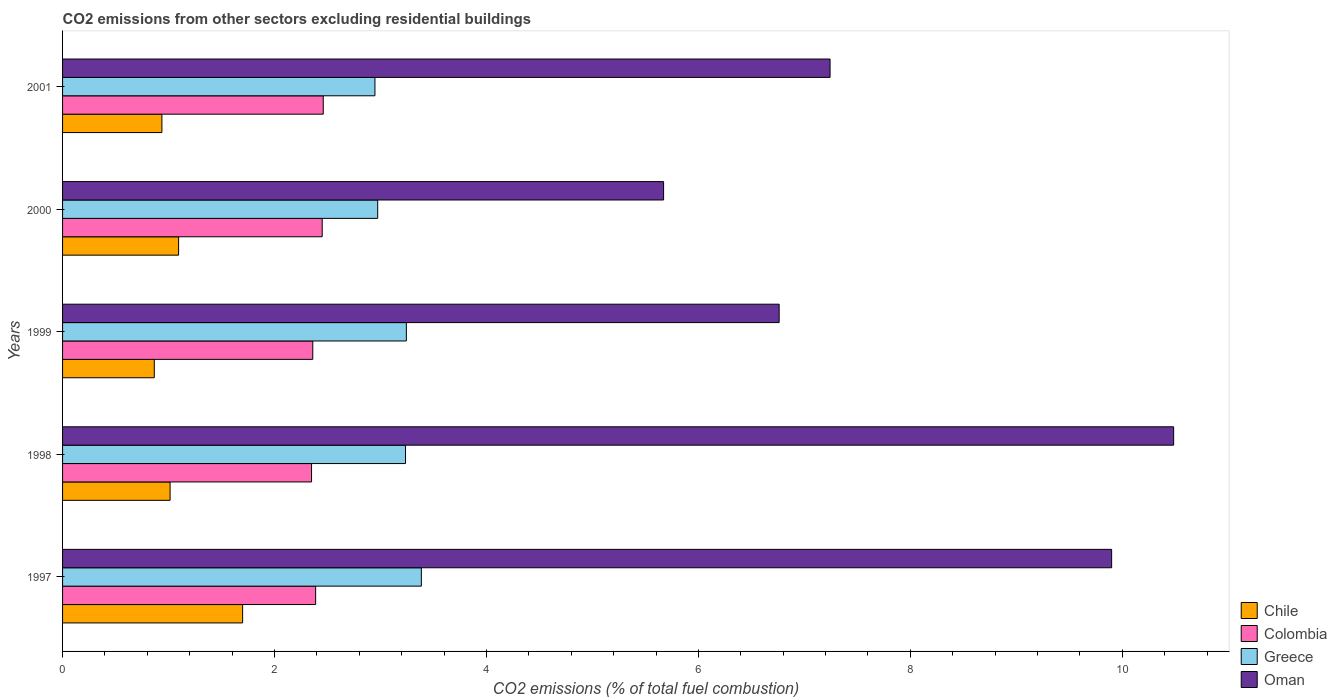How many different coloured bars are there?
Ensure brevity in your answer.  4. Are the number of bars per tick equal to the number of legend labels?
Give a very brief answer. Yes. How many bars are there on the 5th tick from the top?
Ensure brevity in your answer.  4. What is the label of the 2nd group of bars from the top?
Give a very brief answer. 2000. What is the total CO2 emitted in Colombia in 2001?
Keep it short and to the point. 2.46. Across all years, what is the maximum total CO2 emitted in Greece?
Your answer should be very brief. 3.39. Across all years, what is the minimum total CO2 emitted in Oman?
Ensure brevity in your answer.  5.67. What is the total total CO2 emitted in Colombia in the graph?
Offer a terse response. 12.01. What is the difference between the total CO2 emitted in Colombia in 1997 and that in 1998?
Your answer should be compact. 0.04. What is the difference between the total CO2 emitted in Greece in 2000 and the total CO2 emitted in Oman in 1998?
Your answer should be compact. -7.51. What is the average total CO2 emitted in Oman per year?
Give a very brief answer. 8.01. In the year 2000, what is the difference between the total CO2 emitted in Colombia and total CO2 emitted in Oman?
Keep it short and to the point. -3.22. In how many years, is the total CO2 emitted in Chile greater than 10 ?
Offer a terse response. 0. What is the ratio of the total CO2 emitted in Colombia in 2000 to that in 2001?
Provide a short and direct response. 1. Is the total CO2 emitted in Greece in 1997 less than that in 1999?
Your answer should be very brief. No. Is the difference between the total CO2 emitted in Colombia in 1999 and 2001 greater than the difference between the total CO2 emitted in Oman in 1999 and 2001?
Provide a short and direct response. Yes. What is the difference between the highest and the second highest total CO2 emitted in Greece?
Ensure brevity in your answer.  0.14. What is the difference between the highest and the lowest total CO2 emitted in Greece?
Offer a terse response. 0.44. Is the sum of the total CO2 emitted in Oman in 1999 and 2000 greater than the maximum total CO2 emitted in Chile across all years?
Offer a very short reply. Yes. Is it the case that in every year, the sum of the total CO2 emitted in Chile and total CO2 emitted in Greece is greater than the total CO2 emitted in Colombia?
Offer a terse response. Yes. How many bars are there?
Provide a succinct answer. 20. Are all the bars in the graph horizontal?
Provide a short and direct response. Yes. How many years are there in the graph?
Offer a very short reply. 5. What is the difference between two consecutive major ticks on the X-axis?
Provide a short and direct response. 2. Are the values on the major ticks of X-axis written in scientific E-notation?
Keep it short and to the point. No. Does the graph contain any zero values?
Ensure brevity in your answer.  No. Where does the legend appear in the graph?
Your answer should be very brief. Bottom right. How are the legend labels stacked?
Offer a very short reply. Vertical. What is the title of the graph?
Ensure brevity in your answer.  CO2 emissions from other sectors excluding residential buildings. Does "East Asia (developing only)" appear as one of the legend labels in the graph?
Give a very brief answer. No. What is the label or title of the X-axis?
Ensure brevity in your answer.  CO2 emissions (% of total fuel combustion). What is the CO2 emissions (% of total fuel combustion) of Chile in 1997?
Your answer should be very brief. 1.7. What is the CO2 emissions (% of total fuel combustion) in Colombia in 1997?
Keep it short and to the point. 2.39. What is the CO2 emissions (% of total fuel combustion) of Greece in 1997?
Ensure brevity in your answer.  3.39. What is the CO2 emissions (% of total fuel combustion) in Oman in 1997?
Your answer should be very brief. 9.9. What is the CO2 emissions (% of total fuel combustion) of Chile in 1998?
Provide a succinct answer. 1.01. What is the CO2 emissions (% of total fuel combustion) of Colombia in 1998?
Offer a terse response. 2.35. What is the CO2 emissions (% of total fuel combustion) in Greece in 1998?
Give a very brief answer. 3.24. What is the CO2 emissions (% of total fuel combustion) in Oman in 1998?
Provide a short and direct response. 10.48. What is the CO2 emissions (% of total fuel combustion) of Chile in 1999?
Your answer should be compact. 0.87. What is the CO2 emissions (% of total fuel combustion) in Colombia in 1999?
Provide a succinct answer. 2.36. What is the CO2 emissions (% of total fuel combustion) of Greece in 1999?
Your answer should be very brief. 3.24. What is the CO2 emissions (% of total fuel combustion) of Oman in 1999?
Keep it short and to the point. 6.76. What is the CO2 emissions (% of total fuel combustion) in Chile in 2000?
Your answer should be compact. 1.09. What is the CO2 emissions (% of total fuel combustion) of Colombia in 2000?
Offer a very short reply. 2.45. What is the CO2 emissions (% of total fuel combustion) in Greece in 2000?
Provide a short and direct response. 2.97. What is the CO2 emissions (% of total fuel combustion) in Oman in 2000?
Your response must be concise. 5.67. What is the CO2 emissions (% of total fuel combustion) in Chile in 2001?
Keep it short and to the point. 0.94. What is the CO2 emissions (% of total fuel combustion) of Colombia in 2001?
Your response must be concise. 2.46. What is the CO2 emissions (% of total fuel combustion) in Greece in 2001?
Offer a very short reply. 2.95. What is the CO2 emissions (% of total fuel combustion) of Oman in 2001?
Keep it short and to the point. 7.24. Across all years, what is the maximum CO2 emissions (% of total fuel combustion) in Chile?
Offer a very short reply. 1.7. Across all years, what is the maximum CO2 emissions (% of total fuel combustion) of Colombia?
Give a very brief answer. 2.46. Across all years, what is the maximum CO2 emissions (% of total fuel combustion) of Greece?
Make the answer very short. 3.39. Across all years, what is the maximum CO2 emissions (% of total fuel combustion) in Oman?
Your response must be concise. 10.48. Across all years, what is the minimum CO2 emissions (% of total fuel combustion) in Chile?
Keep it short and to the point. 0.87. Across all years, what is the minimum CO2 emissions (% of total fuel combustion) of Colombia?
Ensure brevity in your answer.  2.35. Across all years, what is the minimum CO2 emissions (% of total fuel combustion) of Greece?
Your answer should be very brief. 2.95. Across all years, what is the minimum CO2 emissions (% of total fuel combustion) of Oman?
Your response must be concise. 5.67. What is the total CO2 emissions (% of total fuel combustion) of Chile in the graph?
Ensure brevity in your answer.  5.61. What is the total CO2 emissions (% of total fuel combustion) of Colombia in the graph?
Provide a short and direct response. 12.01. What is the total CO2 emissions (% of total fuel combustion) of Greece in the graph?
Your answer should be compact. 15.79. What is the total CO2 emissions (% of total fuel combustion) of Oman in the graph?
Give a very brief answer. 40.06. What is the difference between the CO2 emissions (% of total fuel combustion) in Chile in 1997 and that in 1998?
Make the answer very short. 0.68. What is the difference between the CO2 emissions (% of total fuel combustion) in Colombia in 1997 and that in 1998?
Offer a terse response. 0.04. What is the difference between the CO2 emissions (% of total fuel combustion) in Greece in 1997 and that in 1998?
Give a very brief answer. 0.15. What is the difference between the CO2 emissions (% of total fuel combustion) of Oman in 1997 and that in 1998?
Your answer should be very brief. -0.59. What is the difference between the CO2 emissions (% of total fuel combustion) of Chile in 1997 and that in 1999?
Ensure brevity in your answer.  0.83. What is the difference between the CO2 emissions (% of total fuel combustion) of Colombia in 1997 and that in 1999?
Your response must be concise. 0.03. What is the difference between the CO2 emissions (% of total fuel combustion) in Greece in 1997 and that in 1999?
Make the answer very short. 0.14. What is the difference between the CO2 emissions (% of total fuel combustion) of Oman in 1997 and that in 1999?
Ensure brevity in your answer.  3.14. What is the difference between the CO2 emissions (% of total fuel combustion) in Chile in 1997 and that in 2000?
Make the answer very short. 0.6. What is the difference between the CO2 emissions (% of total fuel combustion) of Colombia in 1997 and that in 2000?
Provide a succinct answer. -0.06. What is the difference between the CO2 emissions (% of total fuel combustion) in Greece in 1997 and that in 2000?
Provide a succinct answer. 0.41. What is the difference between the CO2 emissions (% of total fuel combustion) of Oman in 1997 and that in 2000?
Your answer should be compact. 4.23. What is the difference between the CO2 emissions (% of total fuel combustion) in Chile in 1997 and that in 2001?
Provide a short and direct response. 0.76. What is the difference between the CO2 emissions (% of total fuel combustion) in Colombia in 1997 and that in 2001?
Give a very brief answer. -0.07. What is the difference between the CO2 emissions (% of total fuel combustion) in Greece in 1997 and that in 2001?
Provide a succinct answer. 0.44. What is the difference between the CO2 emissions (% of total fuel combustion) of Oman in 1997 and that in 2001?
Offer a terse response. 2.66. What is the difference between the CO2 emissions (% of total fuel combustion) of Chile in 1998 and that in 1999?
Give a very brief answer. 0.15. What is the difference between the CO2 emissions (% of total fuel combustion) of Colombia in 1998 and that in 1999?
Make the answer very short. -0.01. What is the difference between the CO2 emissions (% of total fuel combustion) of Greece in 1998 and that in 1999?
Ensure brevity in your answer.  -0.01. What is the difference between the CO2 emissions (% of total fuel combustion) in Oman in 1998 and that in 1999?
Keep it short and to the point. 3.72. What is the difference between the CO2 emissions (% of total fuel combustion) in Chile in 1998 and that in 2000?
Make the answer very short. -0.08. What is the difference between the CO2 emissions (% of total fuel combustion) in Colombia in 1998 and that in 2000?
Keep it short and to the point. -0.1. What is the difference between the CO2 emissions (% of total fuel combustion) in Greece in 1998 and that in 2000?
Provide a short and direct response. 0.26. What is the difference between the CO2 emissions (% of total fuel combustion) in Oman in 1998 and that in 2000?
Make the answer very short. 4.81. What is the difference between the CO2 emissions (% of total fuel combustion) of Chile in 1998 and that in 2001?
Make the answer very short. 0.08. What is the difference between the CO2 emissions (% of total fuel combustion) of Colombia in 1998 and that in 2001?
Your answer should be very brief. -0.11. What is the difference between the CO2 emissions (% of total fuel combustion) in Greece in 1998 and that in 2001?
Ensure brevity in your answer.  0.29. What is the difference between the CO2 emissions (% of total fuel combustion) in Oman in 1998 and that in 2001?
Ensure brevity in your answer.  3.24. What is the difference between the CO2 emissions (% of total fuel combustion) in Chile in 1999 and that in 2000?
Give a very brief answer. -0.23. What is the difference between the CO2 emissions (% of total fuel combustion) in Colombia in 1999 and that in 2000?
Give a very brief answer. -0.09. What is the difference between the CO2 emissions (% of total fuel combustion) of Greece in 1999 and that in 2000?
Give a very brief answer. 0.27. What is the difference between the CO2 emissions (% of total fuel combustion) in Oman in 1999 and that in 2000?
Keep it short and to the point. 1.09. What is the difference between the CO2 emissions (% of total fuel combustion) in Chile in 1999 and that in 2001?
Provide a short and direct response. -0.07. What is the difference between the CO2 emissions (% of total fuel combustion) in Colombia in 1999 and that in 2001?
Keep it short and to the point. -0.1. What is the difference between the CO2 emissions (% of total fuel combustion) in Greece in 1999 and that in 2001?
Ensure brevity in your answer.  0.3. What is the difference between the CO2 emissions (% of total fuel combustion) in Oman in 1999 and that in 2001?
Provide a short and direct response. -0.48. What is the difference between the CO2 emissions (% of total fuel combustion) in Chile in 2000 and that in 2001?
Give a very brief answer. 0.16. What is the difference between the CO2 emissions (% of total fuel combustion) of Colombia in 2000 and that in 2001?
Your answer should be very brief. -0.01. What is the difference between the CO2 emissions (% of total fuel combustion) of Greece in 2000 and that in 2001?
Your answer should be very brief. 0.03. What is the difference between the CO2 emissions (% of total fuel combustion) in Oman in 2000 and that in 2001?
Offer a very short reply. -1.57. What is the difference between the CO2 emissions (% of total fuel combustion) of Chile in 1997 and the CO2 emissions (% of total fuel combustion) of Colombia in 1998?
Offer a terse response. -0.65. What is the difference between the CO2 emissions (% of total fuel combustion) of Chile in 1997 and the CO2 emissions (% of total fuel combustion) of Greece in 1998?
Your response must be concise. -1.54. What is the difference between the CO2 emissions (% of total fuel combustion) in Chile in 1997 and the CO2 emissions (% of total fuel combustion) in Oman in 1998?
Keep it short and to the point. -8.79. What is the difference between the CO2 emissions (% of total fuel combustion) of Colombia in 1997 and the CO2 emissions (% of total fuel combustion) of Greece in 1998?
Your answer should be compact. -0.85. What is the difference between the CO2 emissions (% of total fuel combustion) in Colombia in 1997 and the CO2 emissions (% of total fuel combustion) in Oman in 1998?
Ensure brevity in your answer.  -8.1. What is the difference between the CO2 emissions (% of total fuel combustion) of Greece in 1997 and the CO2 emissions (% of total fuel combustion) of Oman in 1998?
Provide a succinct answer. -7.1. What is the difference between the CO2 emissions (% of total fuel combustion) of Chile in 1997 and the CO2 emissions (% of total fuel combustion) of Colombia in 1999?
Provide a short and direct response. -0.66. What is the difference between the CO2 emissions (% of total fuel combustion) in Chile in 1997 and the CO2 emissions (% of total fuel combustion) in Greece in 1999?
Offer a terse response. -1.55. What is the difference between the CO2 emissions (% of total fuel combustion) in Chile in 1997 and the CO2 emissions (% of total fuel combustion) in Oman in 1999?
Make the answer very short. -5.06. What is the difference between the CO2 emissions (% of total fuel combustion) in Colombia in 1997 and the CO2 emissions (% of total fuel combustion) in Greece in 1999?
Your answer should be very brief. -0.86. What is the difference between the CO2 emissions (% of total fuel combustion) of Colombia in 1997 and the CO2 emissions (% of total fuel combustion) of Oman in 1999?
Provide a short and direct response. -4.37. What is the difference between the CO2 emissions (% of total fuel combustion) in Greece in 1997 and the CO2 emissions (% of total fuel combustion) in Oman in 1999?
Provide a short and direct response. -3.38. What is the difference between the CO2 emissions (% of total fuel combustion) in Chile in 1997 and the CO2 emissions (% of total fuel combustion) in Colombia in 2000?
Give a very brief answer. -0.75. What is the difference between the CO2 emissions (% of total fuel combustion) of Chile in 1997 and the CO2 emissions (% of total fuel combustion) of Greece in 2000?
Ensure brevity in your answer.  -1.27. What is the difference between the CO2 emissions (% of total fuel combustion) in Chile in 1997 and the CO2 emissions (% of total fuel combustion) in Oman in 2000?
Offer a terse response. -3.97. What is the difference between the CO2 emissions (% of total fuel combustion) of Colombia in 1997 and the CO2 emissions (% of total fuel combustion) of Greece in 2000?
Keep it short and to the point. -0.59. What is the difference between the CO2 emissions (% of total fuel combustion) of Colombia in 1997 and the CO2 emissions (% of total fuel combustion) of Oman in 2000?
Offer a terse response. -3.28. What is the difference between the CO2 emissions (% of total fuel combustion) of Greece in 1997 and the CO2 emissions (% of total fuel combustion) of Oman in 2000?
Your answer should be very brief. -2.29. What is the difference between the CO2 emissions (% of total fuel combustion) of Chile in 1997 and the CO2 emissions (% of total fuel combustion) of Colombia in 2001?
Keep it short and to the point. -0.76. What is the difference between the CO2 emissions (% of total fuel combustion) of Chile in 1997 and the CO2 emissions (% of total fuel combustion) of Greece in 2001?
Offer a very short reply. -1.25. What is the difference between the CO2 emissions (% of total fuel combustion) of Chile in 1997 and the CO2 emissions (% of total fuel combustion) of Oman in 2001?
Make the answer very short. -5.54. What is the difference between the CO2 emissions (% of total fuel combustion) of Colombia in 1997 and the CO2 emissions (% of total fuel combustion) of Greece in 2001?
Provide a short and direct response. -0.56. What is the difference between the CO2 emissions (% of total fuel combustion) in Colombia in 1997 and the CO2 emissions (% of total fuel combustion) in Oman in 2001?
Provide a short and direct response. -4.85. What is the difference between the CO2 emissions (% of total fuel combustion) in Greece in 1997 and the CO2 emissions (% of total fuel combustion) in Oman in 2001?
Give a very brief answer. -3.86. What is the difference between the CO2 emissions (% of total fuel combustion) in Chile in 1998 and the CO2 emissions (% of total fuel combustion) in Colombia in 1999?
Offer a very short reply. -1.35. What is the difference between the CO2 emissions (% of total fuel combustion) in Chile in 1998 and the CO2 emissions (% of total fuel combustion) in Greece in 1999?
Keep it short and to the point. -2.23. What is the difference between the CO2 emissions (% of total fuel combustion) in Chile in 1998 and the CO2 emissions (% of total fuel combustion) in Oman in 1999?
Offer a terse response. -5.75. What is the difference between the CO2 emissions (% of total fuel combustion) of Colombia in 1998 and the CO2 emissions (% of total fuel combustion) of Greece in 1999?
Your answer should be very brief. -0.89. What is the difference between the CO2 emissions (% of total fuel combustion) in Colombia in 1998 and the CO2 emissions (% of total fuel combustion) in Oman in 1999?
Your response must be concise. -4.41. What is the difference between the CO2 emissions (% of total fuel combustion) of Greece in 1998 and the CO2 emissions (% of total fuel combustion) of Oman in 1999?
Ensure brevity in your answer.  -3.53. What is the difference between the CO2 emissions (% of total fuel combustion) in Chile in 1998 and the CO2 emissions (% of total fuel combustion) in Colombia in 2000?
Give a very brief answer. -1.44. What is the difference between the CO2 emissions (% of total fuel combustion) of Chile in 1998 and the CO2 emissions (% of total fuel combustion) of Greece in 2000?
Make the answer very short. -1.96. What is the difference between the CO2 emissions (% of total fuel combustion) in Chile in 1998 and the CO2 emissions (% of total fuel combustion) in Oman in 2000?
Make the answer very short. -4.66. What is the difference between the CO2 emissions (% of total fuel combustion) of Colombia in 1998 and the CO2 emissions (% of total fuel combustion) of Greece in 2000?
Your answer should be compact. -0.62. What is the difference between the CO2 emissions (% of total fuel combustion) in Colombia in 1998 and the CO2 emissions (% of total fuel combustion) in Oman in 2000?
Provide a succinct answer. -3.32. What is the difference between the CO2 emissions (% of total fuel combustion) in Greece in 1998 and the CO2 emissions (% of total fuel combustion) in Oman in 2000?
Your response must be concise. -2.44. What is the difference between the CO2 emissions (% of total fuel combustion) of Chile in 1998 and the CO2 emissions (% of total fuel combustion) of Colombia in 2001?
Offer a very short reply. -1.45. What is the difference between the CO2 emissions (% of total fuel combustion) in Chile in 1998 and the CO2 emissions (% of total fuel combustion) in Greece in 2001?
Provide a short and direct response. -1.93. What is the difference between the CO2 emissions (% of total fuel combustion) of Chile in 1998 and the CO2 emissions (% of total fuel combustion) of Oman in 2001?
Make the answer very short. -6.23. What is the difference between the CO2 emissions (% of total fuel combustion) of Colombia in 1998 and the CO2 emissions (% of total fuel combustion) of Greece in 2001?
Make the answer very short. -0.6. What is the difference between the CO2 emissions (% of total fuel combustion) in Colombia in 1998 and the CO2 emissions (% of total fuel combustion) in Oman in 2001?
Your response must be concise. -4.89. What is the difference between the CO2 emissions (% of total fuel combustion) of Greece in 1998 and the CO2 emissions (% of total fuel combustion) of Oman in 2001?
Ensure brevity in your answer.  -4.01. What is the difference between the CO2 emissions (% of total fuel combustion) of Chile in 1999 and the CO2 emissions (% of total fuel combustion) of Colombia in 2000?
Ensure brevity in your answer.  -1.58. What is the difference between the CO2 emissions (% of total fuel combustion) of Chile in 1999 and the CO2 emissions (% of total fuel combustion) of Greece in 2000?
Keep it short and to the point. -2.11. What is the difference between the CO2 emissions (% of total fuel combustion) in Chile in 1999 and the CO2 emissions (% of total fuel combustion) in Oman in 2000?
Give a very brief answer. -4.81. What is the difference between the CO2 emissions (% of total fuel combustion) in Colombia in 1999 and the CO2 emissions (% of total fuel combustion) in Greece in 2000?
Offer a terse response. -0.61. What is the difference between the CO2 emissions (% of total fuel combustion) in Colombia in 1999 and the CO2 emissions (% of total fuel combustion) in Oman in 2000?
Make the answer very short. -3.31. What is the difference between the CO2 emissions (% of total fuel combustion) of Greece in 1999 and the CO2 emissions (% of total fuel combustion) of Oman in 2000?
Offer a very short reply. -2.43. What is the difference between the CO2 emissions (% of total fuel combustion) in Chile in 1999 and the CO2 emissions (% of total fuel combustion) in Colombia in 2001?
Make the answer very short. -1.59. What is the difference between the CO2 emissions (% of total fuel combustion) in Chile in 1999 and the CO2 emissions (% of total fuel combustion) in Greece in 2001?
Your response must be concise. -2.08. What is the difference between the CO2 emissions (% of total fuel combustion) of Chile in 1999 and the CO2 emissions (% of total fuel combustion) of Oman in 2001?
Give a very brief answer. -6.38. What is the difference between the CO2 emissions (% of total fuel combustion) in Colombia in 1999 and the CO2 emissions (% of total fuel combustion) in Greece in 2001?
Offer a very short reply. -0.59. What is the difference between the CO2 emissions (% of total fuel combustion) in Colombia in 1999 and the CO2 emissions (% of total fuel combustion) in Oman in 2001?
Ensure brevity in your answer.  -4.88. What is the difference between the CO2 emissions (% of total fuel combustion) in Greece in 1999 and the CO2 emissions (% of total fuel combustion) in Oman in 2001?
Provide a short and direct response. -4. What is the difference between the CO2 emissions (% of total fuel combustion) in Chile in 2000 and the CO2 emissions (% of total fuel combustion) in Colombia in 2001?
Give a very brief answer. -1.37. What is the difference between the CO2 emissions (% of total fuel combustion) of Chile in 2000 and the CO2 emissions (% of total fuel combustion) of Greece in 2001?
Provide a short and direct response. -1.85. What is the difference between the CO2 emissions (% of total fuel combustion) of Chile in 2000 and the CO2 emissions (% of total fuel combustion) of Oman in 2001?
Offer a very short reply. -6.15. What is the difference between the CO2 emissions (% of total fuel combustion) of Colombia in 2000 and the CO2 emissions (% of total fuel combustion) of Greece in 2001?
Provide a succinct answer. -0.5. What is the difference between the CO2 emissions (% of total fuel combustion) of Colombia in 2000 and the CO2 emissions (% of total fuel combustion) of Oman in 2001?
Give a very brief answer. -4.79. What is the difference between the CO2 emissions (% of total fuel combustion) in Greece in 2000 and the CO2 emissions (% of total fuel combustion) in Oman in 2001?
Keep it short and to the point. -4.27. What is the average CO2 emissions (% of total fuel combustion) of Chile per year?
Offer a terse response. 1.12. What is the average CO2 emissions (% of total fuel combustion) of Colombia per year?
Make the answer very short. 2.4. What is the average CO2 emissions (% of total fuel combustion) of Greece per year?
Offer a terse response. 3.16. What is the average CO2 emissions (% of total fuel combustion) of Oman per year?
Offer a terse response. 8.01. In the year 1997, what is the difference between the CO2 emissions (% of total fuel combustion) of Chile and CO2 emissions (% of total fuel combustion) of Colombia?
Provide a succinct answer. -0.69. In the year 1997, what is the difference between the CO2 emissions (% of total fuel combustion) of Chile and CO2 emissions (% of total fuel combustion) of Greece?
Your response must be concise. -1.69. In the year 1997, what is the difference between the CO2 emissions (% of total fuel combustion) in Chile and CO2 emissions (% of total fuel combustion) in Oman?
Keep it short and to the point. -8.2. In the year 1997, what is the difference between the CO2 emissions (% of total fuel combustion) of Colombia and CO2 emissions (% of total fuel combustion) of Greece?
Your answer should be very brief. -1. In the year 1997, what is the difference between the CO2 emissions (% of total fuel combustion) in Colombia and CO2 emissions (% of total fuel combustion) in Oman?
Keep it short and to the point. -7.51. In the year 1997, what is the difference between the CO2 emissions (% of total fuel combustion) in Greece and CO2 emissions (% of total fuel combustion) in Oman?
Keep it short and to the point. -6.51. In the year 1998, what is the difference between the CO2 emissions (% of total fuel combustion) of Chile and CO2 emissions (% of total fuel combustion) of Colombia?
Offer a terse response. -1.33. In the year 1998, what is the difference between the CO2 emissions (% of total fuel combustion) of Chile and CO2 emissions (% of total fuel combustion) of Greece?
Provide a short and direct response. -2.22. In the year 1998, what is the difference between the CO2 emissions (% of total fuel combustion) in Chile and CO2 emissions (% of total fuel combustion) in Oman?
Provide a short and direct response. -9.47. In the year 1998, what is the difference between the CO2 emissions (% of total fuel combustion) of Colombia and CO2 emissions (% of total fuel combustion) of Greece?
Offer a terse response. -0.89. In the year 1998, what is the difference between the CO2 emissions (% of total fuel combustion) of Colombia and CO2 emissions (% of total fuel combustion) of Oman?
Your answer should be compact. -8.14. In the year 1998, what is the difference between the CO2 emissions (% of total fuel combustion) in Greece and CO2 emissions (% of total fuel combustion) in Oman?
Provide a succinct answer. -7.25. In the year 1999, what is the difference between the CO2 emissions (% of total fuel combustion) of Chile and CO2 emissions (% of total fuel combustion) of Colombia?
Your response must be concise. -1.5. In the year 1999, what is the difference between the CO2 emissions (% of total fuel combustion) in Chile and CO2 emissions (% of total fuel combustion) in Greece?
Your answer should be compact. -2.38. In the year 1999, what is the difference between the CO2 emissions (% of total fuel combustion) of Chile and CO2 emissions (% of total fuel combustion) of Oman?
Your answer should be very brief. -5.9. In the year 1999, what is the difference between the CO2 emissions (% of total fuel combustion) in Colombia and CO2 emissions (% of total fuel combustion) in Greece?
Provide a short and direct response. -0.88. In the year 1999, what is the difference between the CO2 emissions (% of total fuel combustion) in Colombia and CO2 emissions (% of total fuel combustion) in Oman?
Ensure brevity in your answer.  -4.4. In the year 1999, what is the difference between the CO2 emissions (% of total fuel combustion) of Greece and CO2 emissions (% of total fuel combustion) of Oman?
Make the answer very short. -3.52. In the year 2000, what is the difference between the CO2 emissions (% of total fuel combustion) of Chile and CO2 emissions (% of total fuel combustion) of Colombia?
Give a very brief answer. -1.36. In the year 2000, what is the difference between the CO2 emissions (% of total fuel combustion) of Chile and CO2 emissions (% of total fuel combustion) of Greece?
Give a very brief answer. -1.88. In the year 2000, what is the difference between the CO2 emissions (% of total fuel combustion) in Chile and CO2 emissions (% of total fuel combustion) in Oman?
Offer a terse response. -4.58. In the year 2000, what is the difference between the CO2 emissions (% of total fuel combustion) in Colombia and CO2 emissions (% of total fuel combustion) in Greece?
Give a very brief answer. -0.52. In the year 2000, what is the difference between the CO2 emissions (% of total fuel combustion) in Colombia and CO2 emissions (% of total fuel combustion) in Oman?
Offer a very short reply. -3.22. In the year 2000, what is the difference between the CO2 emissions (% of total fuel combustion) of Greece and CO2 emissions (% of total fuel combustion) of Oman?
Give a very brief answer. -2.7. In the year 2001, what is the difference between the CO2 emissions (% of total fuel combustion) of Chile and CO2 emissions (% of total fuel combustion) of Colombia?
Offer a very short reply. -1.52. In the year 2001, what is the difference between the CO2 emissions (% of total fuel combustion) in Chile and CO2 emissions (% of total fuel combustion) in Greece?
Provide a short and direct response. -2.01. In the year 2001, what is the difference between the CO2 emissions (% of total fuel combustion) of Chile and CO2 emissions (% of total fuel combustion) of Oman?
Ensure brevity in your answer.  -6.31. In the year 2001, what is the difference between the CO2 emissions (% of total fuel combustion) of Colombia and CO2 emissions (% of total fuel combustion) of Greece?
Make the answer very short. -0.49. In the year 2001, what is the difference between the CO2 emissions (% of total fuel combustion) in Colombia and CO2 emissions (% of total fuel combustion) in Oman?
Offer a terse response. -4.78. In the year 2001, what is the difference between the CO2 emissions (% of total fuel combustion) in Greece and CO2 emissions (% of total fuel combustion) in Oman?
Provide a short and direct response. -4.29. What is the ratio of the CO2 emissions (% of total fuel combustion) in Chile in 1997 to that in 1998?
Your response must be concise. 1.67. What is the ratio of the CO2 emissions (% of total fuel combustion) of Colombia in 1997 to that in 1998?
Give a very brief answer. 1.02. What is the ratio of the CO2 emissions (% of total fuel combustion) of Greece in 1997 to that in 1998?
Ensure brevity in your answer.  1.05. What is the ratio of the CO2 emissions (% of total fuel combustion) in Oman in 1997 to that in 1998?
Ensure brevity in your answer.  0.94. What is the ratio of the CO2 emissions (% of total fuel combustion) of Chile in 1997 to that in 1999?
Provide a succinct answer. 1.96. What is the ratio of the CO2 emissions (% of total fuel combustion) of Colombia in 1997 to that in 1999?
Your response must be concise. 1.01. What is the ratio of the CO2 emissions (% of total fuel combustion) of Greece in 1997 to that in 1999?
Provide a succinct answer. 1.04. What is the ratio of the CO2 emissions (% of total fuel combustion) of Oman in 1997 to that in 1999?
Make the answer very short. 1.46. What is the ratio of the CO2 emissions (% of total fuel combustion) in Chile in 1997 to that in 2000?
Give a very brief answer. 1.55. What is the ratio of the CO2 emissions (% of total fuel combustion) of Colombia in 1997 to that in 2000?
Offer a terse response. 0.97. What is the ratio of the CO2 emissions (% of total fuel combustion) of Greece in 1997 to that in 2000?
Provide a succinct answer. 1.14. What is the ratio of the CO2 emissions (% of total fuel combustion) in Oman in 1997 to that in 2000?
Provide a short and direct response. 1.75. What is the ratio of the CO2 emissions (% of total fuel combustion) of Chile in 1997 to that in 2001?
Offer a very short reply. 1.81. What is the ratio of the CO2 emissions (% of total fuel combustion) in Colombia in 1997 to that in 2001?
Provide a short and direct response. 0.97. What is the ratio of the CO2 emissions (% of total fuel combustion) of Greece in 1997 to that in 2001?
Your answer should be compact. 1.15. What is the ratio of the CO2 emissions (% of total fuel combustion) of Oman in 1997 to that in 2001?
Your response must be concise. 1.37. What is the ratio of the CO2 emissions (% of total fuel combustion) of Chile in 1998 to that in 1999?
Your response must be concise. 1.17. What is the ratio of the CO2 emissions (% of total fuel combustion) of Colombia in 1998 to that in 1999?
Give a very brief answer. 0.99. What is the ratio of the CO2 emissions (% of total fuel combustion) of Greece in 1998 to that in 1999?
Your answer should be very brief. 1. What is the ratio of the CO2 emissions (% of total fuel combustion) in Oman in 1998 to that in 1999?
Your response must be concise. 1.55. What is the ratio of the CO2 emissions (% of total fuel combustion) of Chile in 1998 to that in 2000?
Offer a very short reply. 0.93. What is the ratio of the CO2 emissions (% of total fuel combustion) of Colombia in 1998 to that in 2000?
Give a very brief answer. 0.96. What is the ratio of the CO2 emissions (% of total fuel combustion) of Greece in 1998 to that in 2000?
Make the answer very short. 1.09. What is the ratio of the CO2 emissions (% of total fuel combustion) of Oman in 1998 to that in 2000?
Offer a terse response. 1.85. What is the ratio of the CO2 emissions (% of total fuel combustion) in Chile in 1998 to that in 2001?
Your answer should be very brief. 1.08. What is the ratio of the CO2 emissions (% of total fuel combustion) in Colombia in 1998 to that in 2001?
Keep it short and to the point. 0.96. What is the ratio of the CO2 emissions (% of total fuel combustion) of Greece in 1998 to that in 2001?
Your response must be concise. 1.1. What is the ratio of the CO2 emissions (% of total fuel combustion) in Oman in 1998 to that in 2001?
Keep it short and to the point. 1.45. What is the ratio of the CO2 emissions (% of total fuel combustion) of Chile in 1999 to that in 2000?
Ensure brevity in your answer.  0.79. What is the ratio of the CO2 emissions (% of total fuel combustion) of Colombia in 1999 to that in 2000?
Keep it short and to the point. 0.96. What is the ratio of the CO2 emissions (% of total fuel combustion) in Oman in 1999 to that in 2000?
Keep it short and to the point. 1.19. What is the ratio of the CO2 emissions (% of total fuel combustion) of Chile in 1999 to that in 2001?
Your response must be concise. 0.92. What is the ratio of the CO2 emissions (% of total fuel combustion) in Colombia in 1999 to that in 2001?
Your response must be concise. 0.96. What is the ratio of the CO2 emissions (% of total fuel combustion) of Greece in 1999 to that in 2001?
Provide a short and direct response. 1.1. What is the ratio of the CO2 emissions (% of total fuel combustion) in Oman in 1999 to that in 2001?
Your answer should be very brief. 0.93. What is the ratio of the CO2 emissions (% of total fuel combustion) of Chile in 2000 to that in 2001?
Your response must be concise. 1.17. What is the ratio of the CO2 emissions (% of total fuel combustion) in Greece in 2000 to that in 2001?
Your answer should be very brief. 1.01. What is the ratio of the CO2 emissions (% of total fuel combustion) in Oman in 2000 to that in 2001?
Offer a very short reply. 0.78. What is the difference between the highest and the second highest CO2 emissions (% of total fuel combustion) of Chile?
Offer a terse response. 0.6. What is the difference between the highest and the second highest CO2 emissions (% of total fuel combustion) in Colombia?
Offer a very short reply. 0.01. What is the difference between the highest and the second highest CO2 emissions (% of total fuel combustion) of Greece?
Provide a succinct answer. 0.14. What is the difference between the highest and the second highest CO2 emissions (% of total fuel combustion) of Oman?
Offer a very short reply. 0.59. What is the difference between the highest and the lowest CO2 emissions (% of total fuel combustion) of Chile?
Your response must be concise. 0.83. What is the difference between the highest and the lowest CO2 emissions (% of total fuel combustion) of Colombia?
Keep it short and to the point. 0.11. What is the difference between the highest and the lowest CO2 emissions (% of total fuel combustion) in Greece?
Offer a terse response. 0.44. What is the difference between the highest and the lowest CO2 emissions (% of total fuel combustion) in Oman?
Your response must be concise. 4.81. 